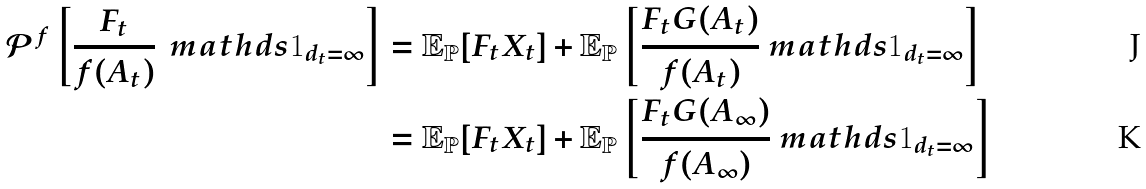<formula> <loc_0><loc_0><loc_500><loc_500>\mathcal { P } ^ { f } \left [ \frac { F _ { t } } { f ( A _ { t } ) } \, \ m a t h d s { 1 } _ { d _ { t } = \infty } \right ] & = \mathbb { E } _ { \mathbb { P } } [ F _ { t } X _ { t } ] + \mathbb { E } _ { \mathbb { P } } \left [ \frac { F _ { t } G ( A _ { t } ) } { f ( A _ { t } ) } \ m a t h d s { 1 } _ { d _ { t } = \infty } \right ] \\ & = \mathbb { E } _ { \mathbb { P } } [ F _ { t } X _ { t } ] + \mathbb { E } _ { \mathbb { P } } \left [ \frac { F _ { t } G ( A _ { \infty } ) } { f ( A _ { \infty } ) } \ m a t h d s { 1 } _ { d _ { t } = \infty } \right ]</formula> 